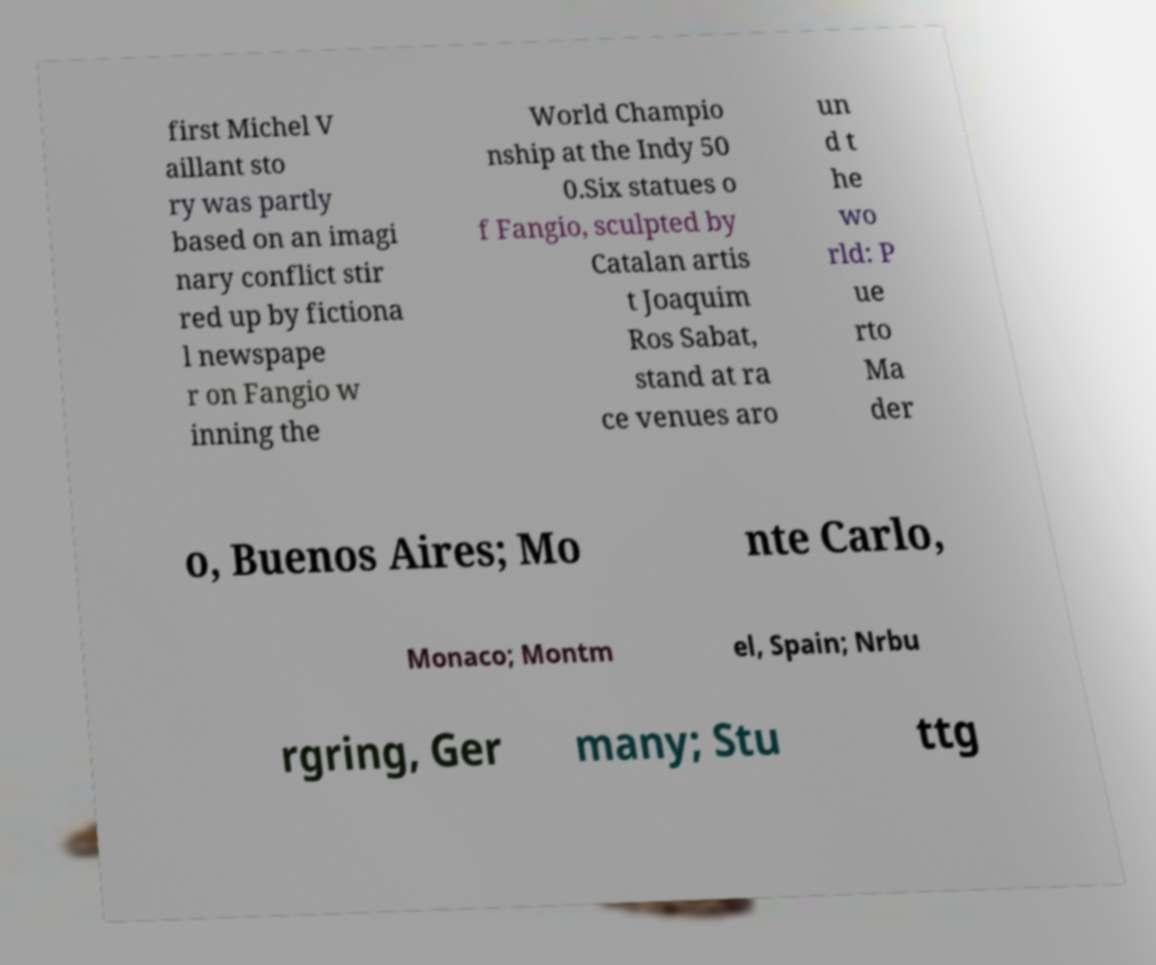Can you accurately transcribe the text from the provided image for me? first Michel V aillant sto ry was partly based on an imagi nary conflict stir red up by fictiona l newspape r on Fangio w inning the World Champio nship at the Indy 50 0.Six statues o f Fangio, sculpted by Catalan artis t Joaquim Ros Sabat, stand at ra ce venues aro un d t he wo rld: P ue rto Ma der o, Buenos Aires; Mo nte Carlo, Monaco; Montm el, Spain; Nrbu rgring, Ger many; Stu ttg 